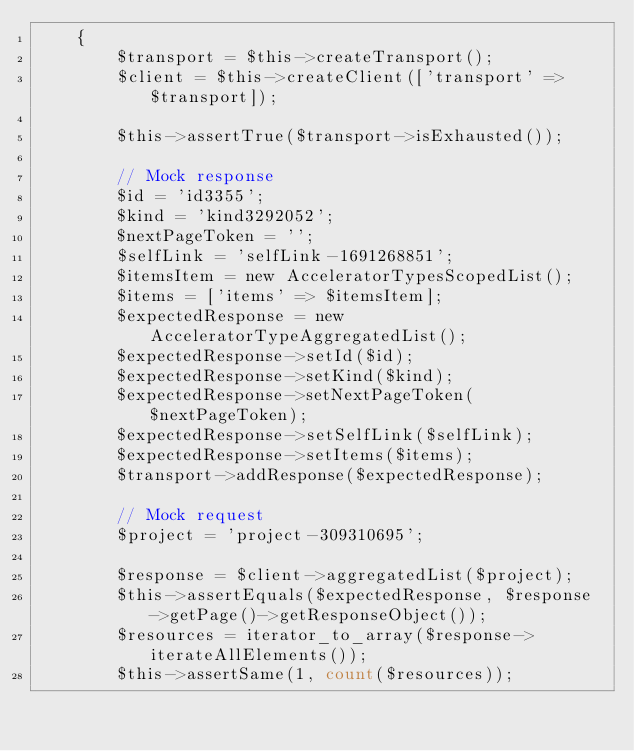Convert code to text. <code><loc_0><loc_0><loc_500><loc_500><_PHP_>    {
        $transport = $this->createTransport();
        $client = $this->createClient(['transport' => $transport]);

        $this->assertTrue($transport->isExhausted());

        // Mock response
        $id = 'id3355';
        $kind = 'kind3292052';
        $nextPageToken = '';
        $selfLink = 'selfLink-1691268851';
        $itemsItem = new AcceleratorTypesScopedList();
        $items = ['items' => $itemsItem];
        $expectedResponse = new AcceleratorTypeAggregatedList();
        $expectedResponse->setId($id);
        $expectedResponse->setKind($kind);
        $expectedResponse->setNextPageToken($nextPageToken);
        $expectedResponse->setSelfLink($selfLink);
        $expectedResponse->setItems($items);
        $transport->addResponse($expectedResponse);

        // Mock request
        $project = 'project-309310695';

        $response = $client->aggregatedList($project);
        $this->assertEquals($expectedResponse, $response->getPage()->getResponseObject());
        $resources = iterator_to_array($response->iterateAllElements());
        $this->assertSame(1, count($resources));
</code> 